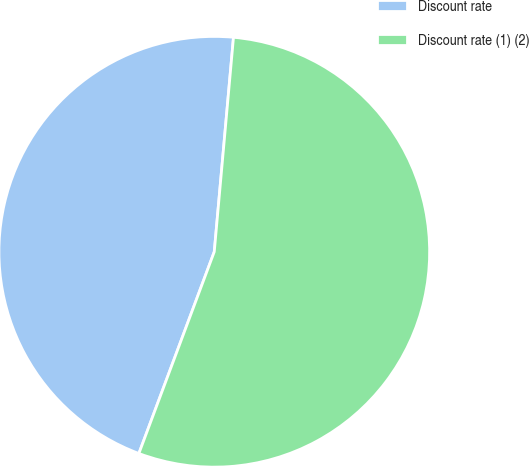Convert chart to OTSL. <chart><loc_0><loc_0><loc_500><loc_500><pie_chart><fcel>Discount rate<fcel>Discount rate (1) (2)<nl><fcel>45.73%<fcel>54.27%<nl></chart> 